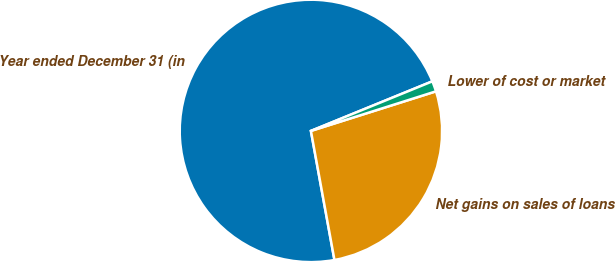<chart> <loc_0><loc_0><loc_500><loc_500><pie_chart><fcel>Year ended December 31 (in<fcel>Net gains on sales of loans<fcel>Lower of cost or market<nl><fcel>71.7%<fcel>27.01%<fcel>1.29%<nl></chart> 